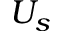Convert formula to latex. <formula><loc_0><loc_0><loc_500><loc_500>U _ { s }</formula> 